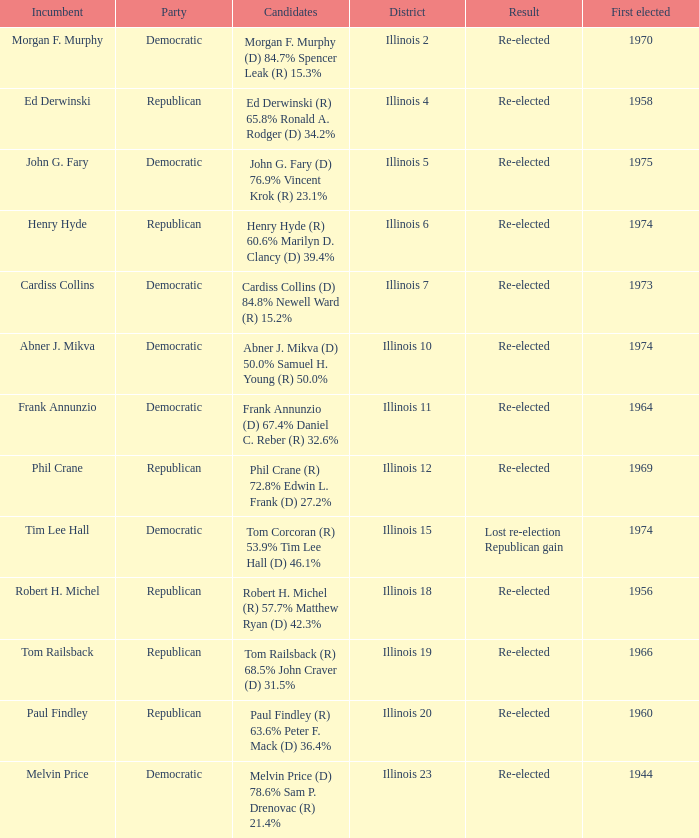Name the first elected for abner j. mikva 1974.0. Can you give me this table as a dict? {'header': ['Incumbent', 'Party', 'Candidates', 'District', 'Result', 'First elected'], 'rows': [['Morgan F. Murphy', 'Democratic', 'Morgan F. Murphy (D) 84.7% Spencer Leak (R) 15.3%', 'Illinois 2', 'Re-elected', '1970'], ['Ed Derwinski', 'Republican', 'Ed Derwinski (R) 65.8% Ronald A. Rodger (D) 34.2%', 'Illinois 4', 'Re-elected', '1958'], ['John G. Fary', 'Democratic', 'John G. Fary (D) 76.9% Vincent Krok (R) 23.1%', 'Illinois 5', 'Re-elected', '1975'], ['Henry Hyde', 'Republican', 'Henry Hyde (R) 60.6% Marilyn D. Clancy (D) 39.4%', 'Illinois 6', 'Re-elected', '1974'], ['Cardiss Collins', 'Democratic', 'Cardiss Collins (D) 84.8% Newell Ward (R) 15.2%', 'Illinois 7', 'Re-elected', '1973'], ['Abner J. Mikva', 'Democratic', 'Abner J. Mikva (D) 50.0% Samuel H. Young (R) 50.0%', 'Illinois 10', 'Re-elected', '1974'], ['Frank Annunzio', 'Democratic', 'Frank Annunzio (D) 67.4% Daniel C. Reber (R) 32.6%', 'Illinois 11', 'Re-elected', '1964'], ['Phil Crane', 'Republican', 'Phil Crane (R) 72.8% Edwin L. Frank (D) 27.2%', 'Illinois 12', 'Re-elected', '1969'], ['Tim Lee Hall', 'Democratic', 'Tom Corcoran (R) 53.9% Tim Lee Hall (D) 46.1%', 'Illinois 15', 'Lost re-election Republican gain', '1974'], ['Robert H. Michel', 'Republican', 'Robert H. Michel (R) 57.7% Matthew Ryan (D) 42.3%', 'Illinois 18', 'Re-elected', '1956'], ['Tom Railsback', 'Republican', 'Tom Railsback (R) 68.5% John Craver (D) 31.5%', 'Illinois 19', 'Re-elected', '1966'], ['Paul Findley', 'Republican', 'Paul Findley (R) 63.6% Peter F. Mack (D) 36.4%', 'Illinois 20', 'Re-elected', '1960'], ['Melvin Price', 'Democratic', 'Melvin Price (D) 78.6% Sam P. Drenovac (R) 21.4%', 'Illinois 23', 'Re-elected', '1944']]} 